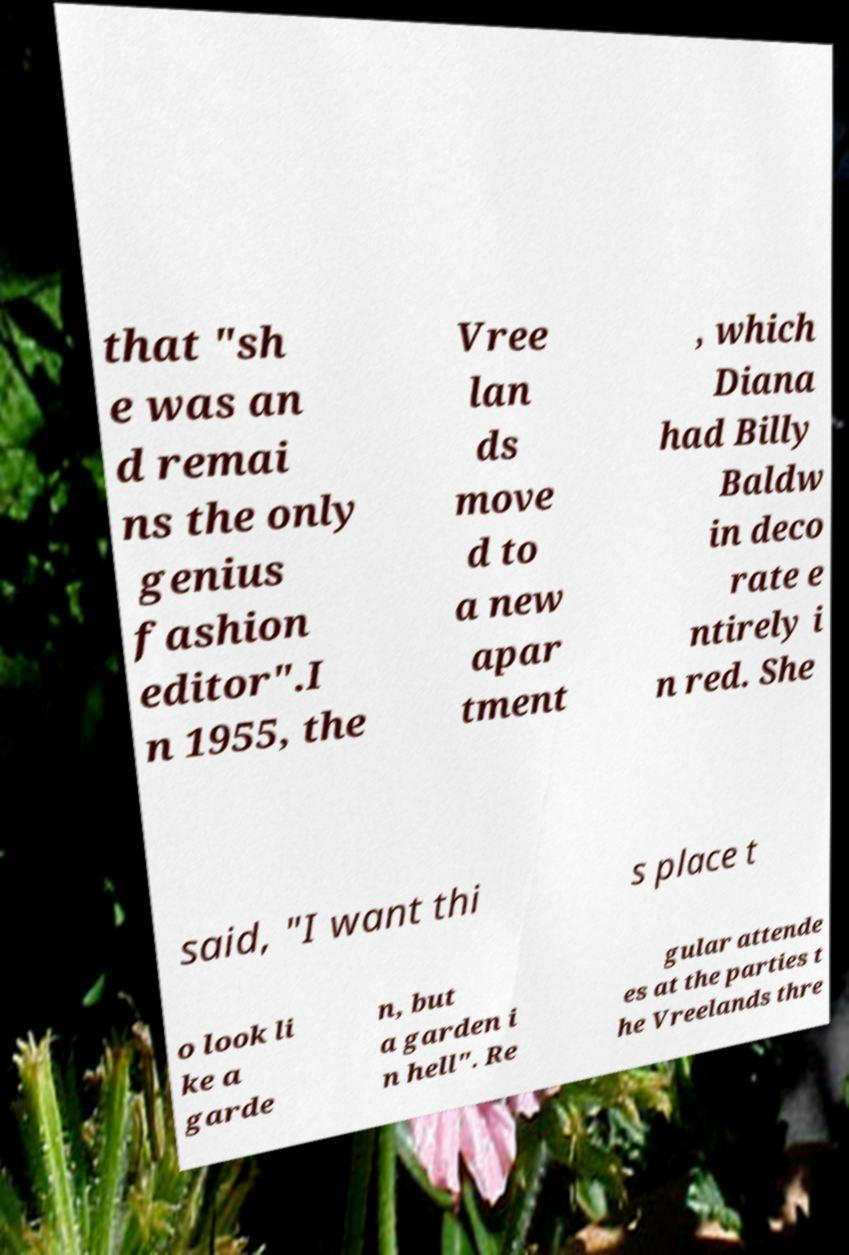For documentation purposes, I need the text within this image transcribed. Could you provide that? that "sh e was an d remai ns the only genius fashion editor".I n 1955, the Vree lan ds move d to a new apar tment , which Diana had Billy Baldw in deco rate e ntirely i n red. She said, "I want thi s place t o look li ke a garde n, but a garden i n hell". Re gular attende es at the parties t he Vreelands thre 